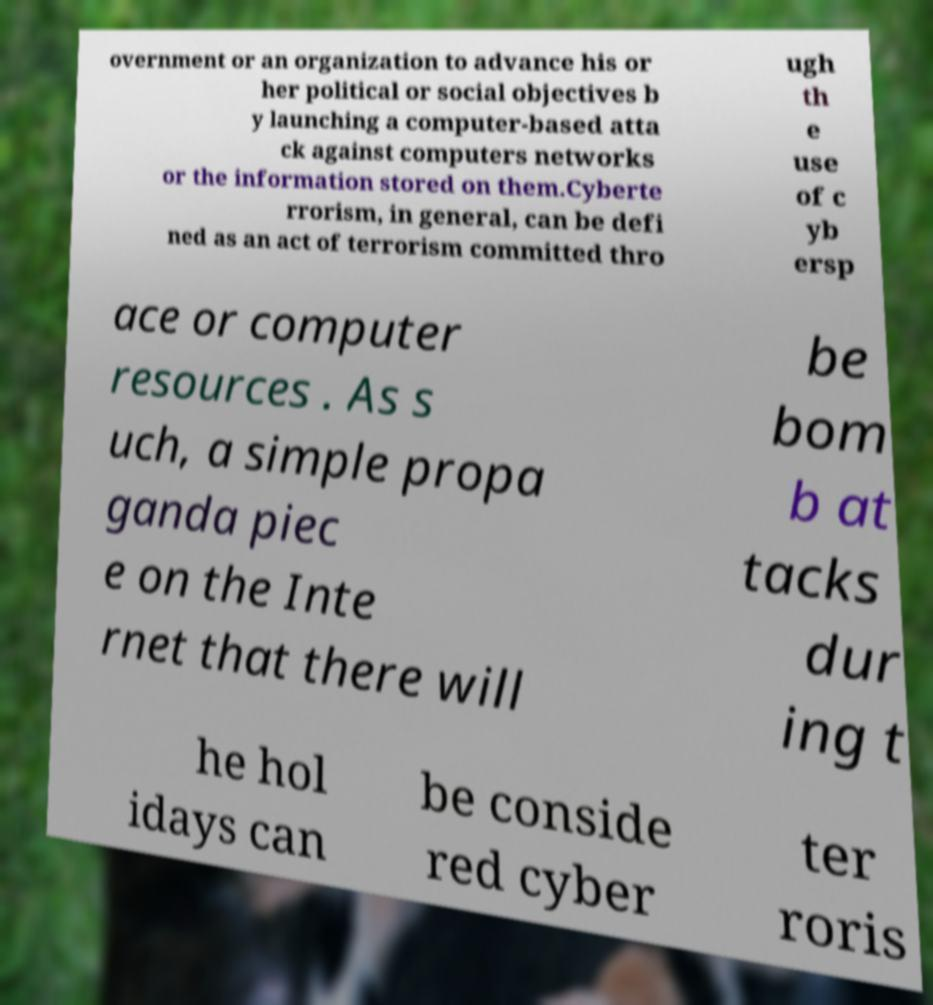There's text embedded in this image that I need extracted. Can you transcribe it verbatim? overnment or an organization to advance his or her political or social objectives b y launching a computer-based atta ck against computers networks or the information stored on them.Cyberte rrorism, in general, can be defi ned as an act of terrorism committed thro ugh th e use of c yb ersp ace or computer resources . As s uch, a simple propa ganda piec e on the Inte rnet that there will be bom b at tacks dur ing t he hol idays can be conside red cyber ter roris 